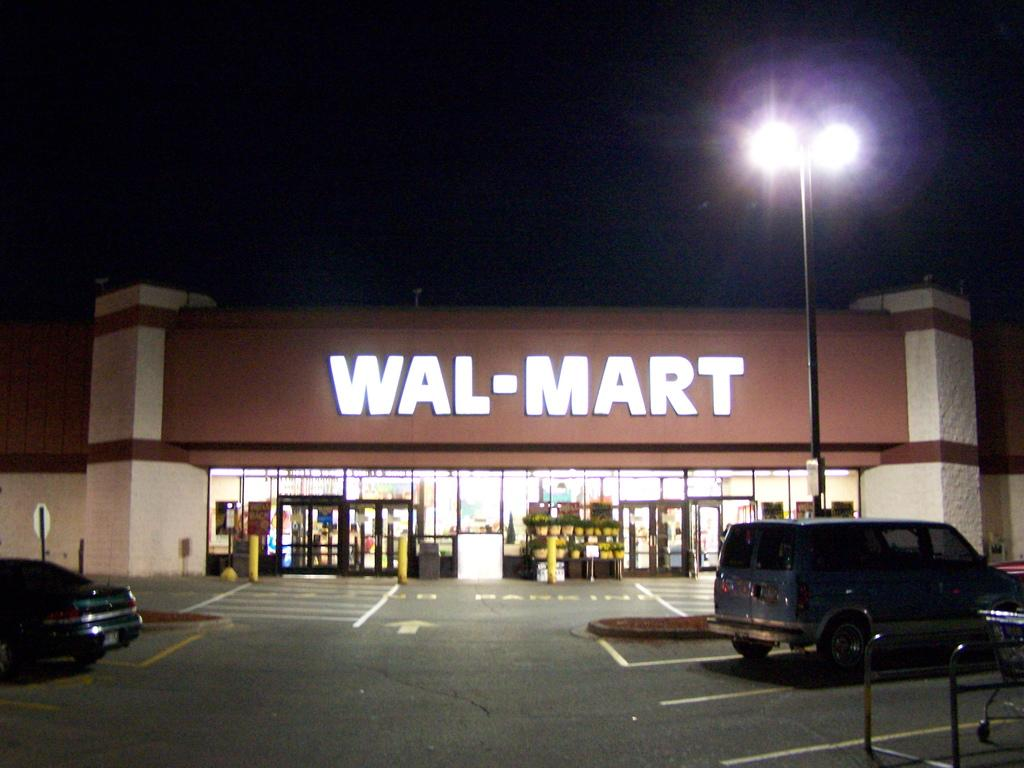Provide a one-sentence caption for the provided image. A Walmart store at night time with some cars at the parking lot. 